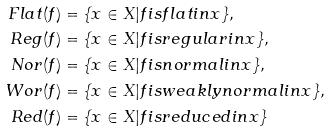<formula> <loc_0><loc_0><loc_500><loc_500>F l a t ( f ) & = \{ x \in X | f i s f l a t i n x \} , \\ R e g ( f ) & = \{ x \in X | f i s r e g u l a r i n x \} , \\ N o r ( f ) & = \{ x \in X | f i s n o r m a l i n x \} , \\ W o r ( f ) & = \{ x \in X | f i s w e a k l y n o r m a l i n x \} , \\ R e d ( f ) & = \{ x \in X | f i s r e d u c e d i n x \}</formula> 